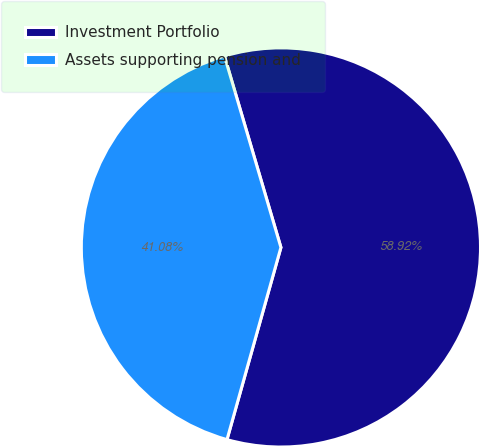Convert chart. <chart><loc_0><loc_0><loc_500><loc_500><pie_chart><fcel>Investment Portfolio<fcel>Assets supporting pension and<nl><fcel>58.92%<fcel>41.08%<nl></chart> 